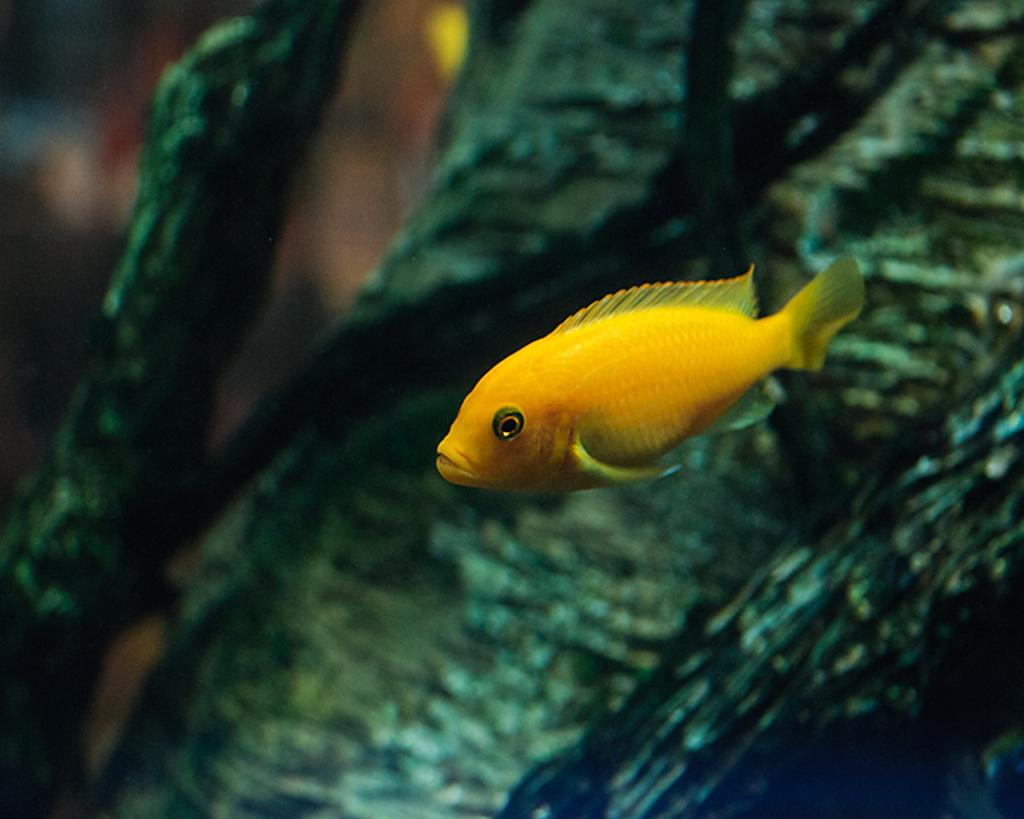What is the main subject of the image? There is a fish in the image. Where is the fish located? The fish is in water. Can you describe the background of the image? The background of the image is blurry. Who is the creator of the fish in the image? The image is a photograph or illustration, not a living creature, so there is no creator of the fish in the image. 